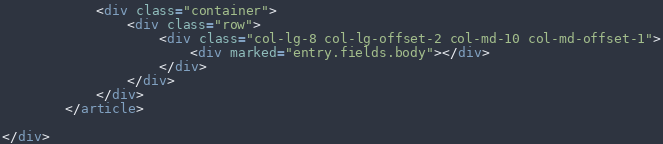Convert code to text. <code><loc_0><loc_0><loc_500><loc_500><_HTML_>            <div class="container">
                <div class="row">
                    <div class="col-lg-8 col-lg-offset-2 col-md-10 col-md-offset-1">
                        <div marked="entry.fields.body"></div>
                    </div>
                </div>
            </div>
        </article>

</div></code> 